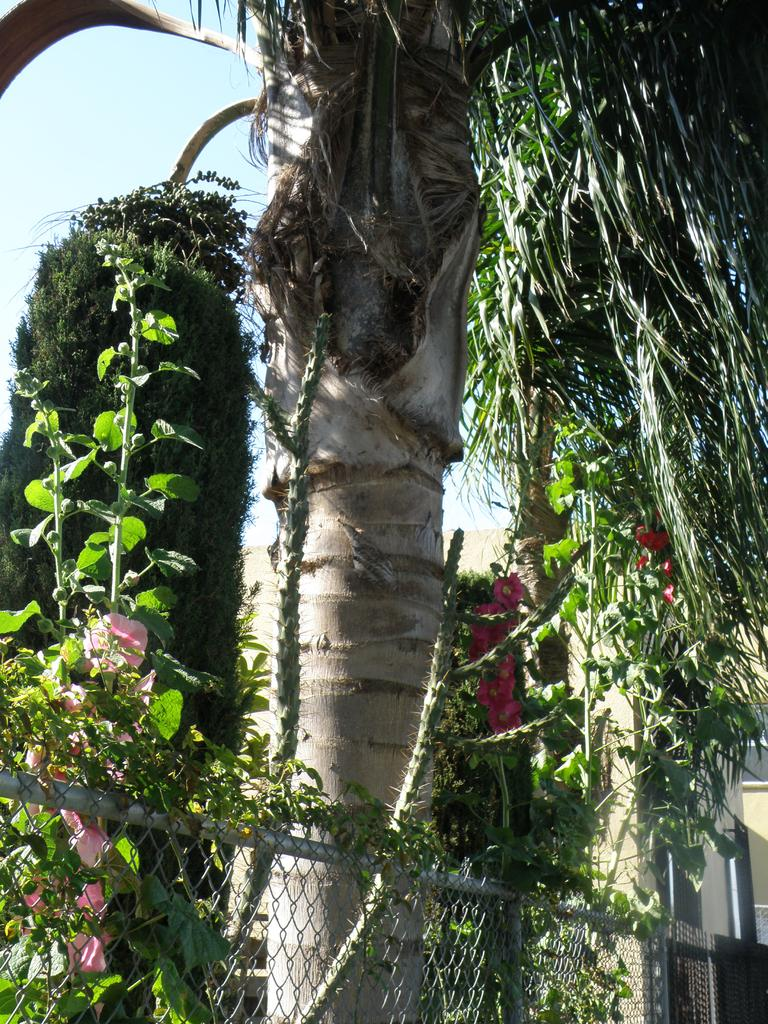What type of vegetation can be seen in the image? The image contains trees. What is located at the bottom of the image? There is a fence at the bottom of the image. What is visible at the top of the image? The sky is visible at the top of the image. What type of flora can be seen on the left side of the image? There are flowers on the left side of the image. What type of yarn is being used to create the hole in the tree in the image? There is no yarn or hole present in the image; it features trees, a fence, flowers, and the sky. 